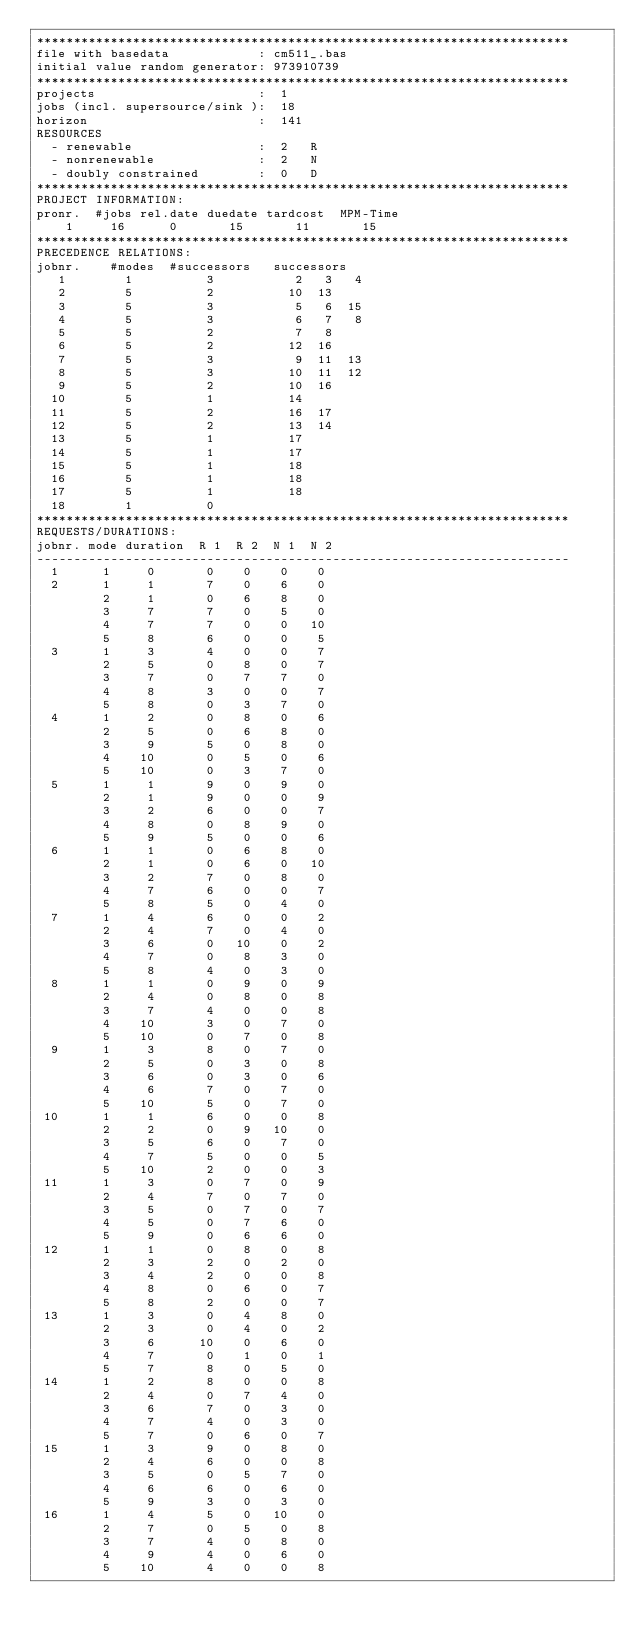Convert code to text. <code><loc_0><loc_0><loc_500><loc_500><_ObjectiveC_>************************************************************************
file with basedata            : cm511_.bas
initial value random generator: 973910739
************************************************************************
projects                      :  1
jobs (incl. supersource/sink ):  18
horizon                       :  141
RESOURCES
  - renewable                 :  2   R
  - nonrenewable              :  2   N
  - doubly constrained        :  0   D
************************************************************************
PROJECT INFORMATION:
pronr.  #jobs rel.date duedate tardcost  MPM-Time
    1     16      0       15       11       15
************************************************************************
PRECEDENCE RELATIONS:
jobnr.    #modes  #successors   successors
   1        1          3           2   3   4
   2        5          2          10  13
   3        5          3           5   6  15
   4        5          3           6   7   8
   5        5          2           7   8
   6        5          2          12  16
   7        5          3           9  11  13
   8        5          3          10  11  12
   9        5          2          10  16
  10        5          1          14
  11        5          2          16  17
  12        5          2          13  14
  13        5          1          17
  14        5          1          17
  15        5          1          18
  16        5          1          18
  17        5          1          18
  18        1          0        
************************************************************************
REQUESTS/DURATIONS:
jobnr. mode duration  R 1  R 2  N 1  N 2
------------------------------------------------------------------------
  1      1     0       0    0    0    0
  2      1     1       7    0    6    0
         2     1       0    6    8    0
         3     7       7    0    5    0
         4     7       7    0    0   10
         5     8       6    0    0    5
  3      1     3       4    0    0    7
         2     5       0    8    0    7
         3     7       0    7    7    0
         4     8       3    0    0    7
         5     8       0    3    7    0
  4      1     2       0    8    0    6
         2     5       0    6    8    0
         3     9       5    0    8    0
         4    10       0    5    0    6
         5    10       0    3    7    0
  5      1     1       9    0    9    0
         2     1       9    0    0    9
         3     2       6    0    0    7
         4     8       0    8    9    0
         5     9       5    0    0    6
  6      1     1       0    6    8    0
         2     1       0    6    0   10
         3     2       7    0    8    0
         4     7       6    0    0    7
         5     8       5    0    4    0
  7      1     4       6    0    0    2
         2     4       7    0    4    0
         3     6       0   10    0    2
         4     7       0    8    3    0
         5     8       4    0    3    0
  8      1     1       0    9    0    9
         2     4       0    8    0    8
         3     7       4    0    0    8
         4    10       3    0    7    0
         5    10       0    7    0    8
  9      1     3       8    0    7    0
         2     5       0    3    0    8
         3     6       0    3    0    6
         4     6       7    0    7    0
         5    10       5    0    7    0
 10      1     1       6    0    0    8
         2     2       0    9   10    0
         3     5       6    0    7    0
         4     7       5    0    0    5
         5    10       2    0    0    3
 11      1     3       0    7    0    9
         2     4       7    0    7    0
         3     5       0    7    0    7
         4     5       0    7    6    0
         5     9       0    6    6    0
 12      1     1       0    8    0    8
         2     3       2    0    2    0
         3     4       2    0    0    8
         4     8       0    6    0    7
         5     8       2    0    0    7
 13      1     3       0    4    8    0
         2     3       0    4    0    2
         3     6      10    0    6    0
         4     7       0    1    0    1
         5     7       8    0    5    0
 14      1     2       8    0    0    8
         2     4       0    7    4    0
         3     6       7    0    3    0
         4     7       4    0    3    0
         5     7       0    6    0    7
 15      1     3       9    0    8    0
         2     4       6    0    0    8
         3     5       0    5    7    0
         4     6       6    0    6    0
         5     9       3    0    3    0
 16      1     4       5    0   10    0
         2     7       0    5    0    8
         3     7       4    0    8    0
         4     9       4    0    6    0
         5    10       4    0    0    8</code> 